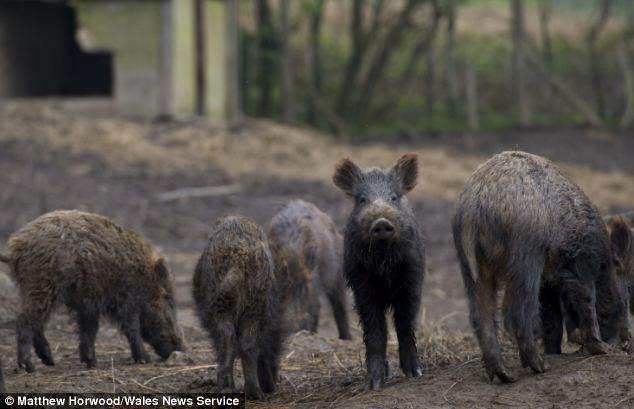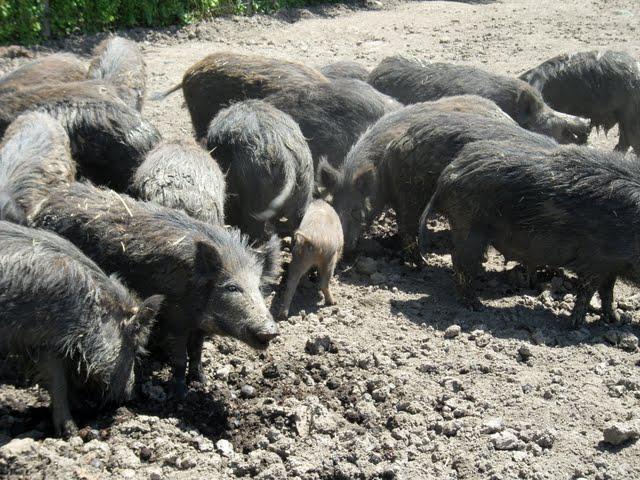The first image is the image on the left, the second image is the image on the right. Assess this claim about the two images: "One image contains no more than 4 pigs.". Correct or not? Answer yes or no. No. The first image is the image on the left, the second image is the image on the right. For the images displayed, is the sentence "One of the images shows only 4 animals." factually correct? Answer yes or no. No. 